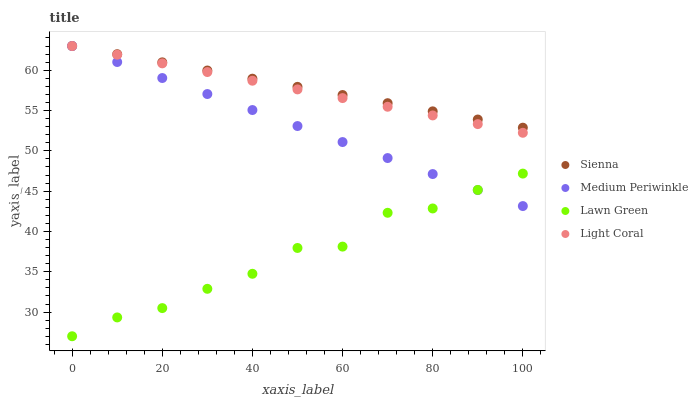Does Lawn Green have the minimum area under the curve?
Answer yes or no. Yes. Does Sienna have the maximum area under the curve?
Answer yes or no. Yes. Does Medium Periwinkle have the minimum area under the curve?
Answer yes or no. No. Does Medium Periwinkle have the maximum area under the curve?
Answer yes or no. No. Is Medium Periwinkle the smoothest?
Answer yes or no. Yes. Is Lawn Green the roughest?
Answer yes or no. Yes. Is Lawn Green the smoothest?
Answer yes or no. No. Is Medium Periwinkle the roughest?
Answer yes or no. No. Does Lawn Green have the lowest value?
Answer yes or no. Yes. Does Medium Periwinkle have the lowest value?
Answer yes or no. No. Does Light Coral have the highest value?
Answer yes or no. Yes. Does Lawn Green have the highest value?
Answer yes or no. No. Is Lawn Green less than Sienna?
Answer yes or no. Yes. Is Light Coral greater than Lawn Green?
Answer yes or no. Yes. Does Sienna intersect Light Coral?
Answer yes or no. Yes. Is Sienna less than Light Coral?
Answer yes or no. No. Is Sienna greater than Light Coral?
Answer yes or no. No. Does Lawn Green intersect Sienna?
Answer yes or no. No. 